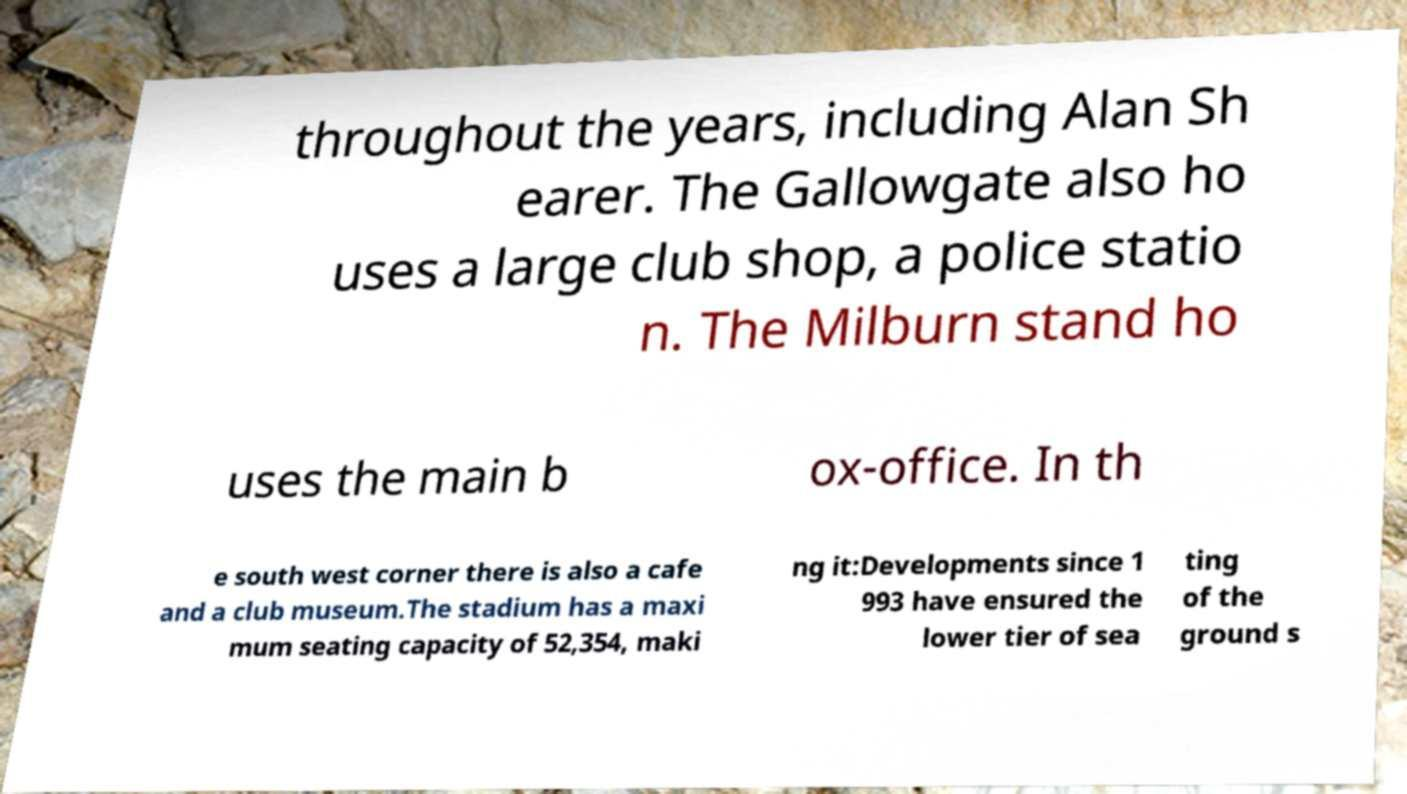Can you read and provide the text displayed in the image?This photo seems to have some interesting text. Can you extract and type it out for me? throughout the years, including Alan Sh earer. The Gallowgate also ho uses a large club shop, a police statio n. The Milburn stand ho uses the main b ox-office. In th e south west corner there is also a cafe and a club museum.The stadium has a maxi mum seating capacity of 52,354, maki ng it:Developments since 1 993 have ensured the lower tier of sea ting of the ground s 